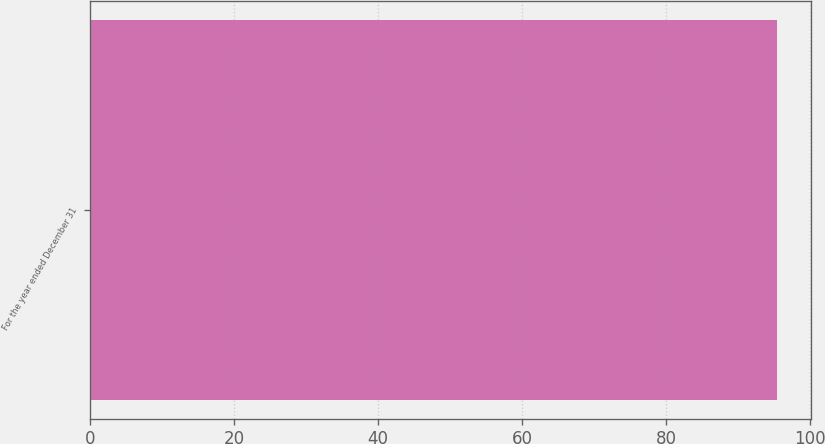Convert chart to OTSL. <chart><loc_0><loc_0><loc_500><loc_500><bar_chart><fcel>For the year ended December 31<nl><fcel>95.4<nl></chart> 